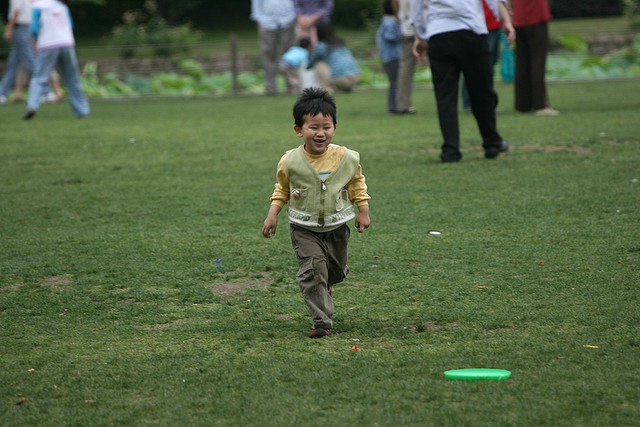Describe the objects in this image and their specific colors. I can see people in black, gray, darkgreen, and tan tones, people in black, gray, and darkgray tones, people in black, lavender, and gray tones, people in black, maroon, and darkgreen tones, and people in black, gray, darkgray, and lightblue tones in this image. 